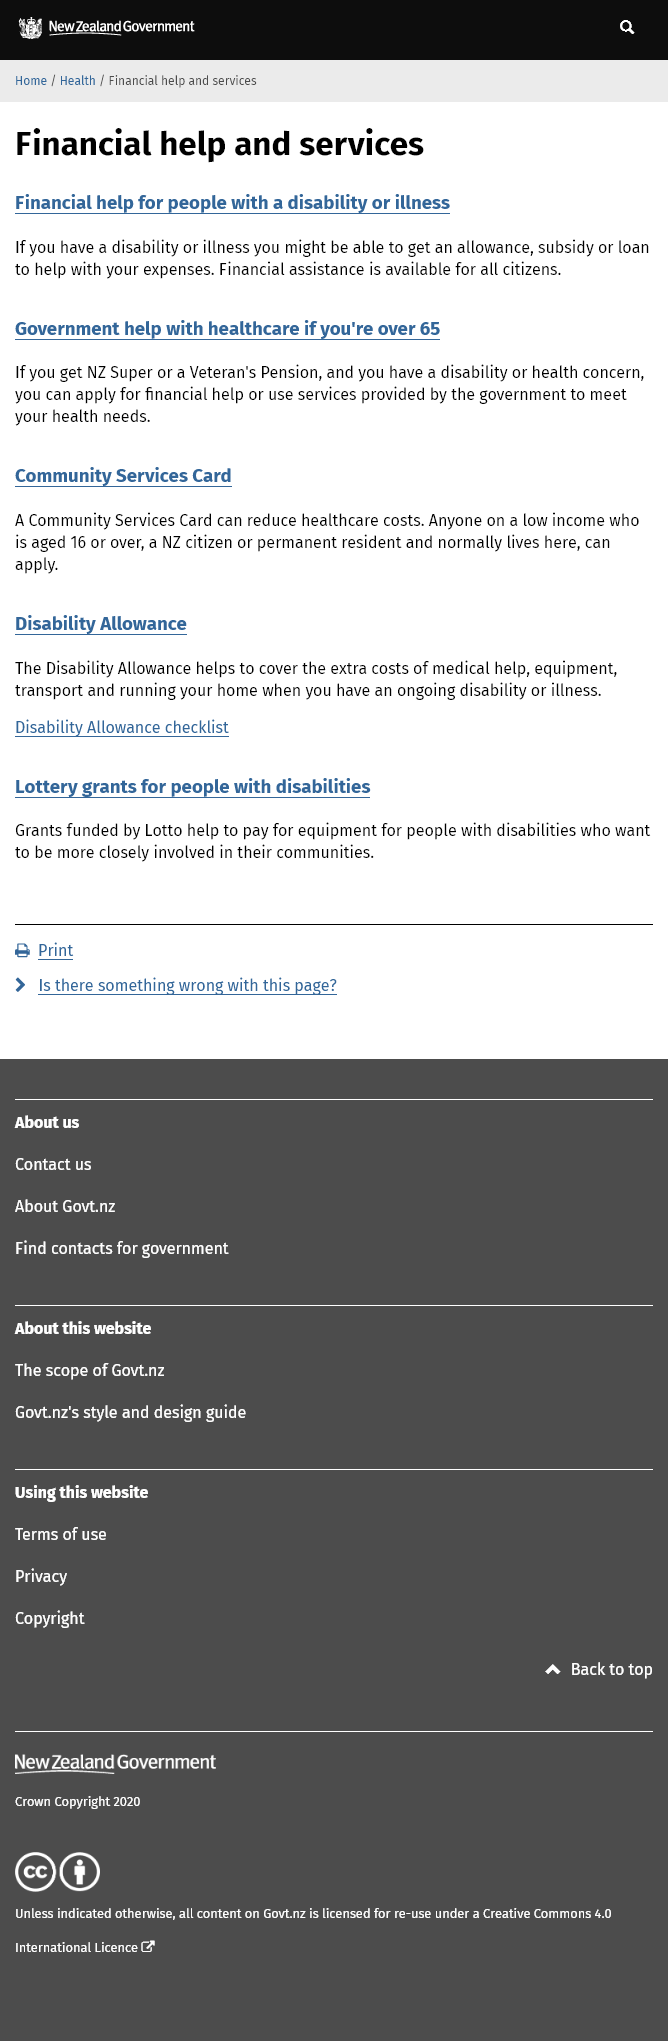List a handful of essential elements in this visual. If you have a disability or health concern and are in need of financial assistance, you must receive a pension from either NZ Super or the Veteran's Pension before you can apply for financial aid. It is possible for individuals with disabilities or illnesses to receive an allowance, subsidy, or loan to assist with their expenses. A Community Services Card is available to individuals in New Zealand who are 16 years or older and have a low income. 